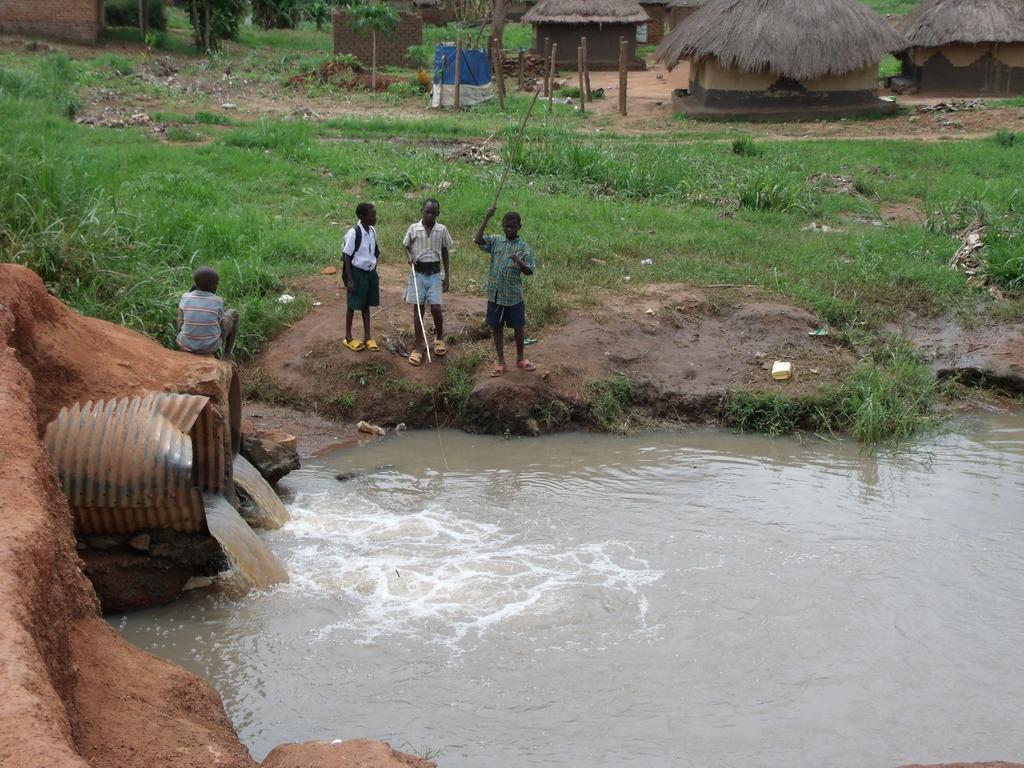Can you describe this image briefly? In this image, there are three kids wearing clothes and standing in front of the canal. There are drainage pipes on the left side of the image. There are huts in the top right of the image. There is a grass in the middle of the image. 